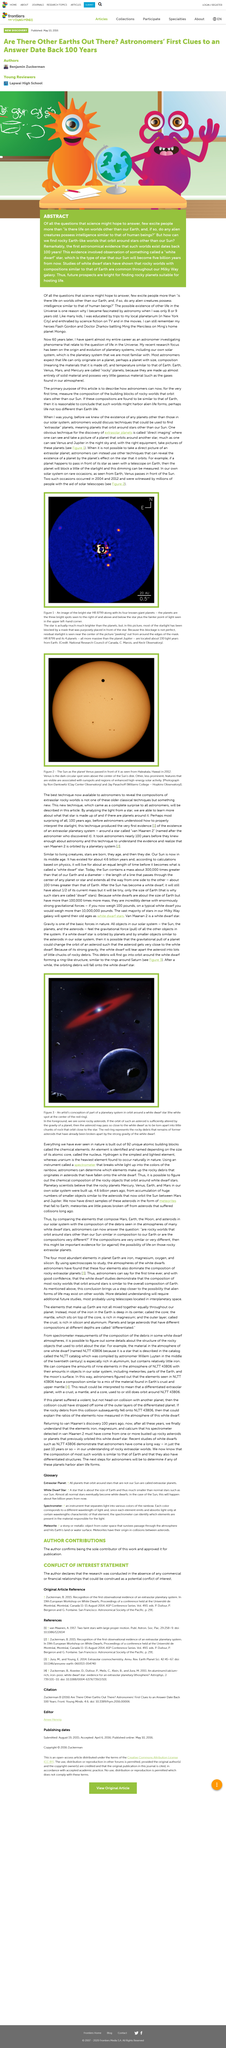Give some essential details in this illustration. The monster on the left of the image used in the Abstract article is orange. The first astronomical evidence of Earth-like worlds that orbit around stars other than our Sun dates back over 100 years. The prospects for finding rocky planets suitable for hosting life are bright, and there are promising future prospects for discovering these planets. 